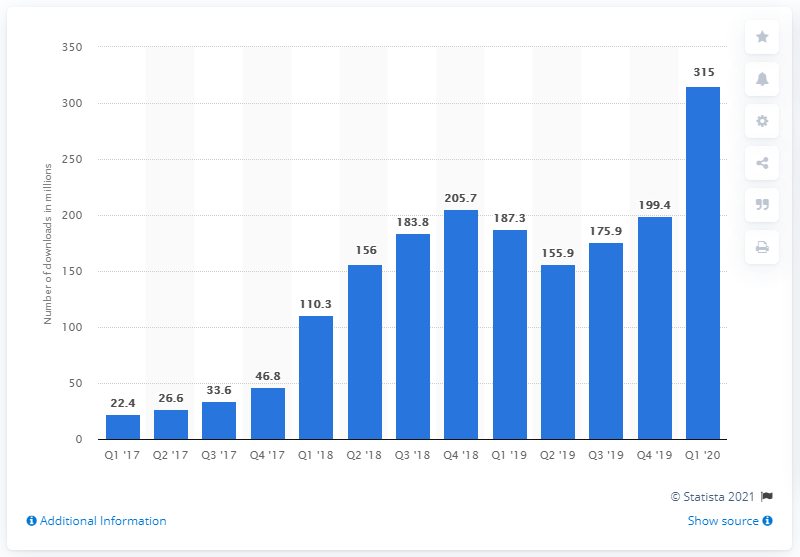Give some essential details in this illustration. TikTok had 315 million downloads in the first quarter of 2020. TikTok has generated a total of 315 lifetime downloads. 